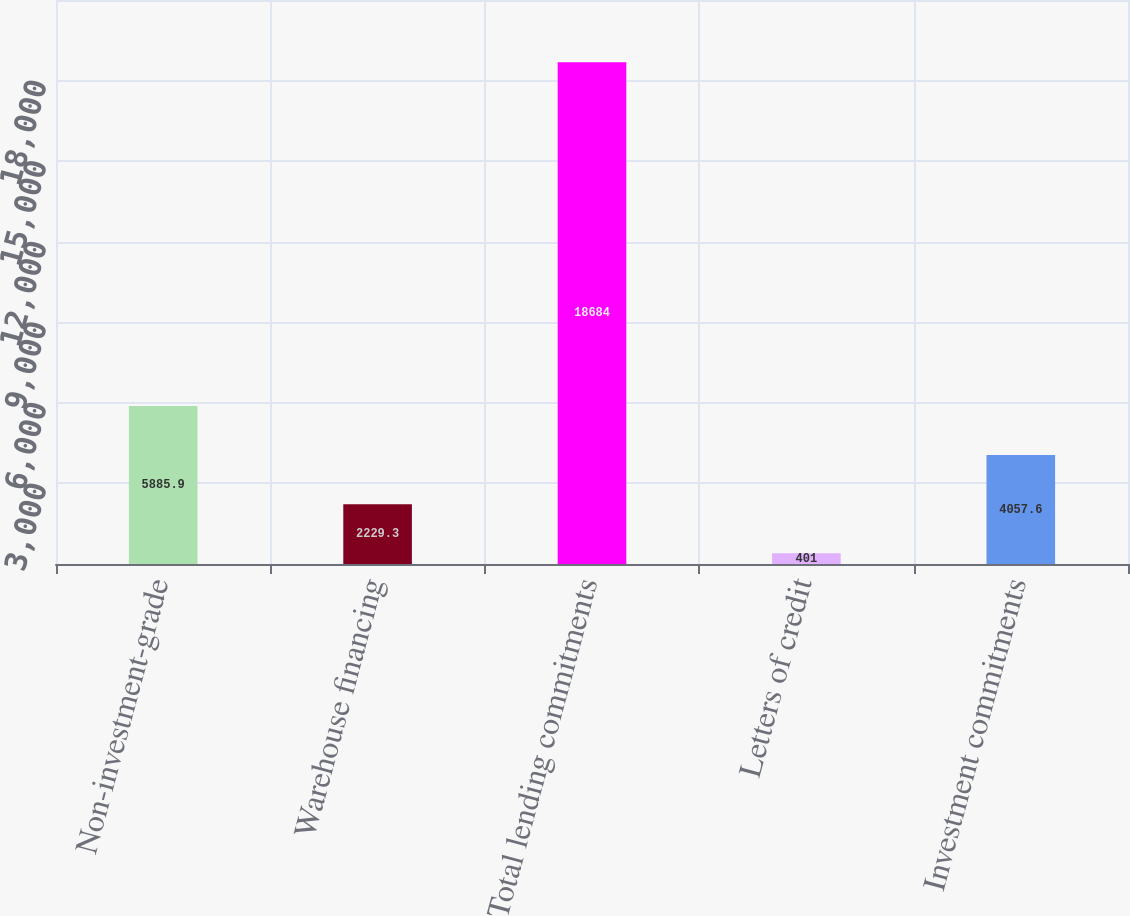Convert chart to OTSL. <chart><loc_0><loc_0><loc_500><loc_500><bar_chart><fcel>Non-investment-grade<fcel>Warehouse financing<fcel>Total lending commitments<fcel>Letters of credit<fcel>Investment commitments<nl><fcel>5885.9<fcel>2229.3<fcel>18684<fcel>401<fcel>4057.6<nl></chart> 